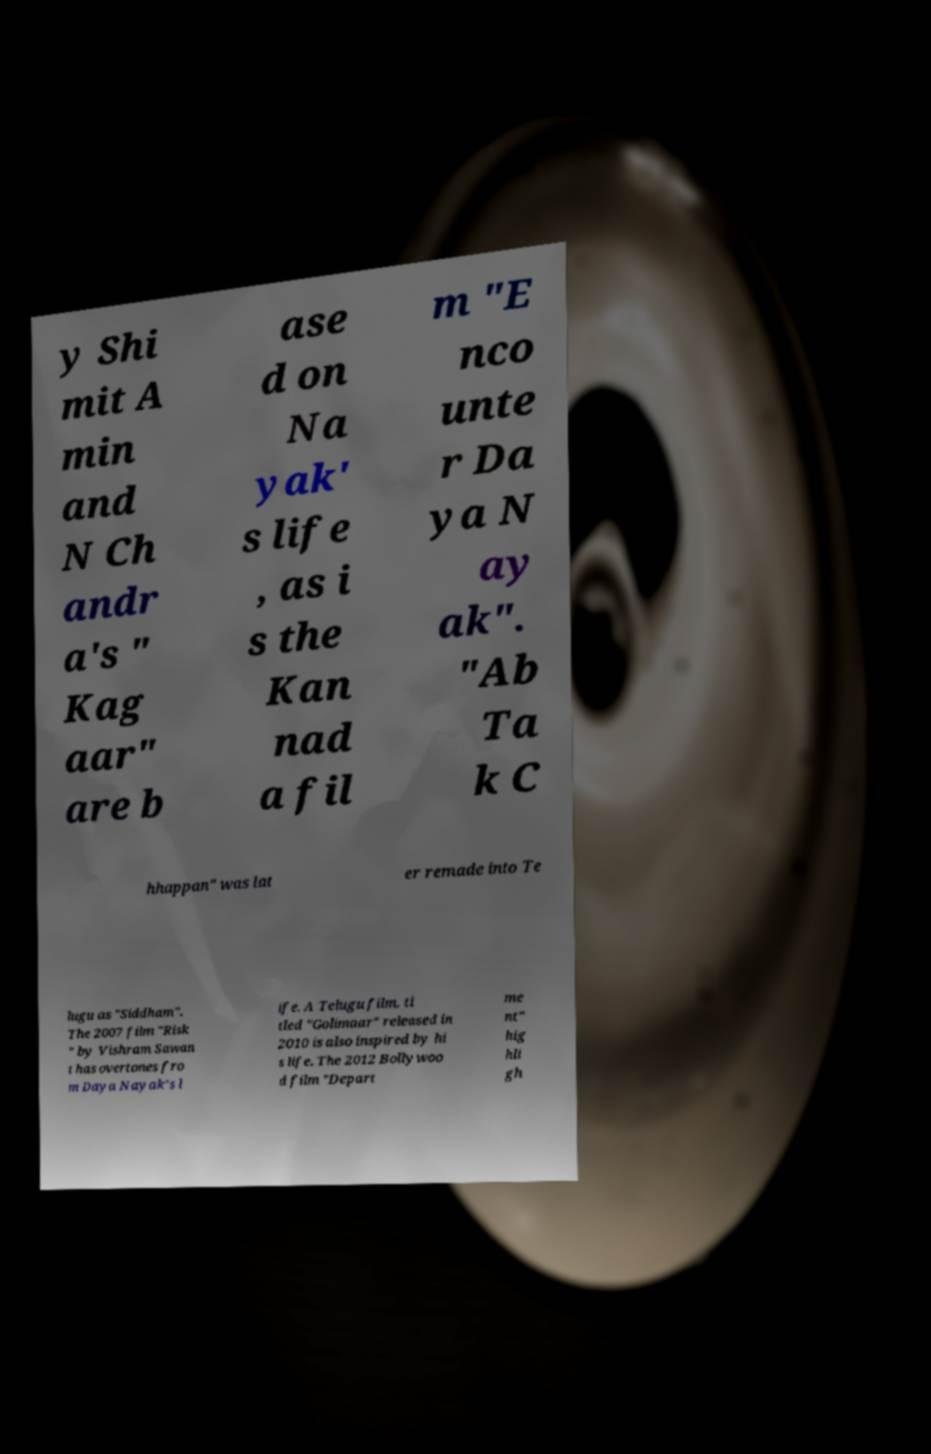Could you assist in decoding the text presented in this image and type it out clearly? y Shi mit A min and N Ch andr a's " Kag aar" are b ase d on Na yak' s life , as i s the Kan nad a fil m "E nco unte r Da ya N ay ak". "Ab Ta k C hhappan" was lat er remade into Te lugu as "Siddham". The 2007 film "Risk " by Vishram Sawan t has overtones fro m Daya Nayak's l ife. A Telugu film, ti tled "Golimaar" released in 2010 is also inspired by hi s life. The 2012 Bollywoo d film "Depart me nt" hig hli gh 